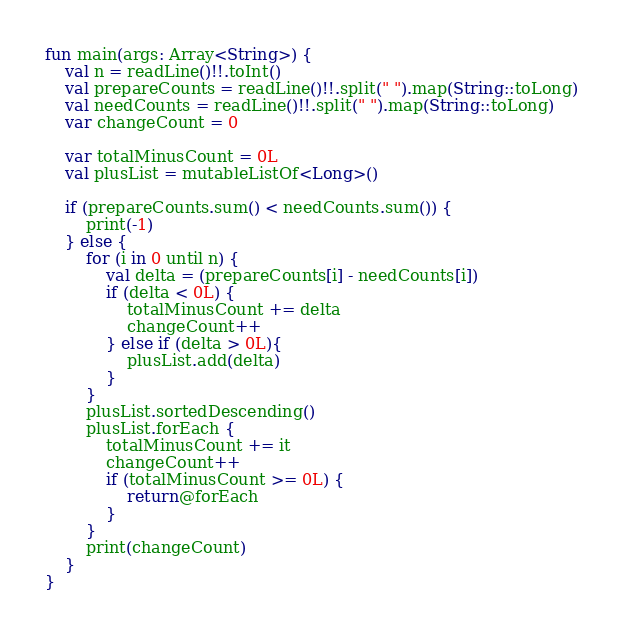<code> <loc_0><loc_0><loc_500><loc_500><_Kotlin_>fun main(args: Array<String>) {
    val n = readLine()!!.toInt()
    val prepareCounts = readLine()!!.split(" ").map(String::toLong)
    val needCounts = readLine()!!.split(" ").map(String::toLong)
    var changeCount = 0

    var totalMinusCount = 0L
    val plusList = mutableListOf<Long>()

    if (prepareCounts.sum() < needCounts.sum()) {
        print(-1)
    } else {
        for (i in 0 until n) {
            val delta = (prepareCounts[i] - needCounts[i])
            if (delta < 0L) {
                totalMinusCount += delta
                changeCount++
            } else if (delta > 0L){
                plusList.add(delta)
            }
        }
        plusList.sortedDescending()
        plusList.forEach {
            totalMinusCount += it
            changeCount++
            if (totalMinusCount >= 0L) {
                return@forEach
            }
        }
        print(changeCount)
    }
}</code> 